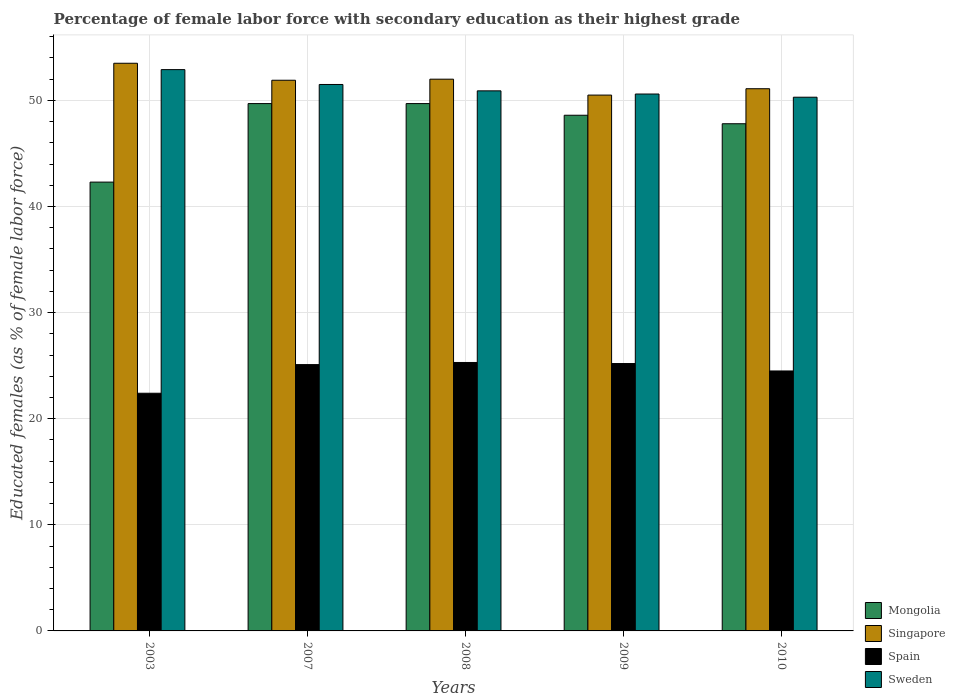How many different coloured bars are there?
Your answer should be compact. 4. Are the number of bars per tick equal to the number of legend labels?
Offer a terse response. Yes. How many bars are there on the 1st tick from the left?
Make the answer very short. 4. How many bars are there on the 4th tick from the right?
Make the answer very short. 4. What is the label of the 5th group of bars from the left?
Your answer should be compact. 2010. In how many cases, is the number of bars for a given year not equal to the number of legend labels?
Your answer should be very brief. 0. What is the percentage of female labor force with secondary education in Mongolia in 2008?
Provide a short and direct response. 49.7. Across all years, what is the maximum percentage of female labor force with secondary education in Spain?
Keep it short and to the point. 25.3. Across all years, what is the minimum percentage of female labor force with secondary education in Mongolia?
Your answer should be compact. 42.3. In which year was the percentage of female labor force with secondary education in Singapore maximum?
Make the answer very short. 2003. What is the total percentage of female labor force with secondary education in Mongolia in the graph?
Give a very brief answer. 238.1. What is the difference between the percentage of female labor force with secondary education in Sweden in 2007 and that in 2009?
Keep it short and to the point. 0.9. What is the average percentage of female labor force with secondary education in Sweden per year?
Ensure brevity in your answer.  51.24. In the year 2010, what is the difference between the percentage of female labor force with secondary education in Spain and percentage of female labor force with secondary education in Sweden?
Give a very brief answer. -25.8. In how many years, is the percentage of female labor force with secondary education in Mongolia greater than 4 %?
Provide a succinct answer. 5. What is the ratio of the percentage of female labor force with secondary education in Spain in 2008 to that in 2009?
Offer a terse response. 1. Is the percentage of female labor force with secondary education in Singapore in 2003 less than that in 2008?
Offer a very short reply. No. Is the difference between the percentage of female labor force with secondary education in Spain in 2003 and 2007 greater than the difference between the percentage of female labor force with secondary education in Sweden in 2003 and 2007?
Provide a succinct answer. No. What is the difference between the highest and the second highest percentage of female labor force with secondary education in Spain?
Offer a very short reply. 0.1. What is the difference between the highest and the lowest percentage of female labor force with secondary education in Singapore?
Provide a short and direct response. 3. Is it the case that in every year, the sum of the percentage of female labor force with secondary education in Spain and percentage of female labor force with secondary education in Singapore is greater than the sum of percentage of female labor force with secondary education in Mongolia and percentage of female labor force with secondary education in Sweden?
Your answer should be compact. No. What does the 2nd bar from the left in 2008 represents?
Your answer should be compact. Singapore. What does the 2nd bar from the right in 2008 represents?
Your answer should be compact. Spain. Is it the case that in every year, the sum of the percentage of female labor force with secondary education in Mongolia and percentage of female labor force with secondary education in Sweden is greater than the percentage of female labor force with secondary education in Singapore?
Offer a very short reply. Yes. How many bars are there?
Provide a short and direct response. 20. How many years are there in the graph?
Your answer should be compact. 5. Where does the legend appear in the graph?
Your answer should be compact. Bottom right. How many legend labels are there?
Provide a short and direct response. 4. How are the legend labels stacked?
Provide a short and direct response. Vertical. What is the title of the graph?
Make the answer very short. Percentage of female labor force with secondary education as their highest grade. What is the label or title of the Y-axis?
Offer a very short reply. Educated females (as % of female labor force). What is the Educated females (as % of female labor force) in Mongolia in 2003?
Offer a terse response. 42.3. What is the Educated females (as % of female labor force) of Singapore in 2003?
Keep it short and to the point. 53.5. What is the Educated females (as % of female labor force) of Spain in 2003?
Offer a very short reply. 22.4. What is the Educated females (as % of female labor force) in Sweden in 2003?
Your answer should be compact. 52.9. What is the Educated females (as % of female labor force) in Mongolia in 2007?
Your response must be concise. 49.7. What is the Educated females (as % of female labor force) in Singapore in 2007?
Offer a terse response. 51.9. What is the Educated females (as % of female labor force) of Spain in 2007?
Your answer should be very brief. 25.1. What is the Educated females (as % of female labor force) in Sweden in 2007?
Provide a short and direct response. 51.5. What is the Educated females (as % of female labor force) of Mongolia in 2008?
Provide a short and direct response. 49.7. What is the Educated females (as % of female labor force) in Singapore in 2008?
Offer a very short reply. 52. What is the Educated females (as % of female labor force) in Spain in 2008?
Keep it short and to the point. 25.3. What is the Educated females (as % of female labor force) of Sweden in 2008?
Provide a succinct answer. 50.9. What is the Educated females (as % of female labor force) of Mongolia in 2009?
Your answer should be very brief. 48.6. What is the Educated females (as % of female labor force) of Singapore in 2009?
Provide a succinct answer. 50.5. What is the Educated females (as % of female labor force) in Spain in 2009?
Give a very brief answer. 25.2. What is the Educated females (as % of female labor force) of Sweden in 2009?
Ensure brevity in your answer.  50.6. What is the Educated females (as % of female labor force) in Mongolia in 2010?
Provide a succinct answer. 47.8. What is the Educated females (as % of female labor force) of Singapore in 2010?
Provide a short and direct response. 51.1. What is the Educated females (as % of female labor force) of Sweden in 2010?
Provide a short and direct response. 50.3. Across all years, what is the maximum Educated females (as % of female labor force) in Mongolia?
Provide a short and direct response. 49.7. Across all years, what is the maximum Educated females (as % of female labor force) of Singapore?
Provide a succinct answer. 53.5. Across all years, what is the maximum Educated females (as % of female labor force) in Spain?
Your answer should be very brief. 25.3. Across all years, what is the maximum Educated females (as % of female labor force) in Sweden?
Your answer should be compact. 52.9. Across all years, what is the minimum Educated females (as % of female labor force) in Mongolia?
Your answer should be compact. 42.3. Across all years, what is the minimum Educated females (as % of female labor force) of Singapore?
Offer a terse response. 50.5. Across all years, what is the minimum Educated females (as % of female labor force) in Spain?
Make the answer very short. 22.4. Across all years, what is the minimum Educated females (as % of female labor force) in Sweden?
Provide a succinct answer. 50.3. What is the total Educated females (as % of female labor force) of Mongolia in the graph?
Provide a succinct answer. 238.1. What is the total Educated females (as % of female labor force) of Singapore in the graph?
Provide a succinct answer. 259. What is the total Educated females (as % of female labor force) of Spain in the graph?
Provide a short and direct response. 122.5. What is the total Educated females (as % of female labor force) of Sweden in the graph?
Provide a succinct answer. 256.2. What is the difference between the Educated females (as % of female labor force) of Mongolia in 2003 and that in 2007?
Offer a very short reply. -7.4. What is the difference between the Educated females (as % of female labor force) in Sweden in 2003 and that in 2007?
Provide a short and direct response. 1.4. What is the difference between the Educated females (as % of female labor force) in Mongolia in 2003 and that in 2008?
Your answer should be very brief. -7.4. What is the difference between the Educated females (as % of female labor force) of Singapore in 2003 and that in 2008?
Offer a terse response. 1.5. What is the difference between the Educated females (as % of female labor force) in Singapore in 2003 and that in 2009?
Make the answer very short. 3. What is the difference between the Educated females (as % of female labor force) of Sweden in 2003 and that in 2009?
Ensure brevity in your answer.  2.3. What is the difference between the Educated females (as % of female labor force) in Mongolia in 2003 and that in 2010?
Keep it short and to the point. -5.5. What is the difference between the Educated females (as % of female labor force) in Singapore in 2003 and that in 2010?
Provide a succinct answer. 2.4. What is the difference between the Educated females (as % of female labor force) in Mongolia in 2007 and that in 2008?
Keep it short and to the point. 0. What is the difference between the Educated females (as % of female labor force) of Sweden in 2007 and that in 2008?
Ensure brevity in your answer.  0.6. What is the difference between the Educated females (as % of female labor force) in Mongolia in 2007 and that in 2009?
Ensure brevity in your answer.  1.1. What is the difference between the Educated females (as % of female labor force) of Singapore in 2007 and that in 2010?
Offer a very short reply. 0.8. What is the difference between the Educated females (as % of female labor force) of Sweden in 2007 and that in 2010?
Give a very brief answer. 1.2. What is the difference between the Educated females (as % of female labor force) of Mongolia in 2008 and that in 2009?
Keep it short and to the point. 1.1. What is the difference between the Educated females (as % of female labor force) of Singapore in 2008 and that in 2009?
Ensure brevity in your answer.  1.5. What is the difference between the Educated females (as % of female labor force) in Singapore in 2008 and that in 2010?
Make the answer very short. 0.9. What is the difference between the Educated females (as % of female labor force) of Mongolia in 2009 and that in 2010?
Offer a terse response. 0.8. What is the difference between the Educated females (as % of female labor force) of Mongolia in 2003 and the Educated females (as % of female labor force) of Spain in 2007?
Ensure brevity in your answer.  17.2. What is the difference between the Educated females (as % of female labor force) in Singapore in 2003 and the Educated females (as % of female labor force) in Spain in 2007?
Offer a terse response. 28.4. What is the difference between the Educated females (as % of female labor force) in Singapore in 2003 and the Educated females (as % of female labor force) in Sweden in 2007?
Offer a very short reply. 2. What is the difference between the Educated females (as % of female labor force) in Spain in 2003 and the Educated females (as % of female labor force) in Sweden in 2007?
Make the answer very short. -29.1. What is the difference between the Educated females (as % of female labor force) in Mongolia in 2003 and the Educated females (as % of female labor force) in Singapore in 2008?
Provide a succinct answer. -9.7. What is the difference between the Educated females (as % of female labor force) in Mongolia in 2003 and the Educated females (as % of female labor force) in Spain in 2008?
Your answer should be compact. 17. What is the difference between the Educated females (as % of female labor force) in Singapore in 2003 and the Educated females (as % of female labor force) in Spain in 2008?
Offer a terse response. 28.2. What is the difference between the Educated females (as % of female labor force) in Spain in 2003 and the Educated females (as % of female labor force) in Sweden in 2008?
Your response must be concise. -28.5. What is the difference between the Educated females (as % of female labor force) in Mongolia in 2003 and the Educated females (as % of female labor force) in Spain in 2009?
Offer a very short reply. 17.1. What is the difference between the Educated females (as % of female labor force) in Mongolia in 2003 and the Educated females (as % of female labor force) in Sweden in 2009?
Your answer should be compact. -8.3. What is the difference between the Educated females (as % of female labor force) of Singapore in 2003 and the Educated females (as % of female labor force) of Spain in 2009?
Provide a succinct answer. 28.3. What is the difference between the Educated females (as % of female labor force) in Singapore in 2003 and the Educated females (as % of female labor force) in Sweden in 2009?
Make the answer very short. 2.9. What is the difference between the Educated females (as % of female labor force) of Spain in 2003 and the Educated females (as % of female labor force) of Sweden in 2009?
Offer a terse response. -28.2. What is the difference between the Educated females (as % of female labor force) of Mongolia in 2003 and the Educated females (as % of female labor force) of Sweden in 2010?
Provide a succinct answer. -8. What is the difference between the Educated females (as % of female labor force) of Singapore in 2003 and the Educated females (as % of female labor force) of Spain in 2010?
Your answer should be compact. 29. What is the difference between the Educated females (as % of female labor force) of Singapore in 2003 and the Educated females (as % of female labor force) of Sweden in 2010?
Offer a terse response. 3.2. What is the difference between the Educated females (as % of female labor force) of Spain in 2003 and the Educated females (as % of female labor force) of Sweden in 2010?
Provide a succinct answer. -27.9. What is the difference between the Educated females (as % of female labor force) of Mongolia in 2007 and the Educated females (as % of female labor force) of Singapore in 2008?
Offer a very short reply. -2.3. What is the difference between the Educated females (as % of female labor force) of Mongolia in 2007 and the Educated females (as % of female labor force) of Spain in 2008?
Your answer should be compact. 24.4. What is the difference between the Educated females (as % of female labor force) in Singapore in 2007 and the Educated females (as % of female labor force) in Spain in 2008?
Make the answer very short. 26.6. What is the difference between the Educated females (as % of female labor force) in Spain in 2007 and the Educated females (as % of female labor force) in Sweden in 2008?
Give a very brief answer. -25.8. What is the difference between the Educated females (as % of female labor force) in Singapore in 2007 and the Educated females (as % of female labor force) in Spain in 2009?
Provide a succinct answer. 26.7. What is the difference between the Educated females (as % of female labor force) in Singapore in 2007 and the Educated females (as % of female labor force) in Sweden in 2009?
Provide a succinct answer. 1.3. What is the difference between the Educated females (as % of female labor force) in Spain in 2007 and the Educated females (as % of female labor force) in Sweden in 2009?
Ensure brevity in your answer.  -25.5. What is the difference between the Educated females (as % of female labor force) of Mongolia in 2007 and the Educated females (as % of female labor force) of Spain in 2010?
Offer a terse response. 25.2. What is the difference between the Educated females (as % of female labor force) of Singapore in 2007 and the Educated females (as % of female labor force) of Spain in 2010?
Offer a terse response. 27.4. What is the difference between the Educated females (as % of female labor force) in Spain in 2007 and the Educated females (as % of female labor force) in Sweden in 2010?
Provide a succinct answer. -25.2. What is the difference between the Educated females (as % of female labor force) of Mongolia in 2008 and the Educated females (as % of female labor force) of Singapore in 2009?
Provide a succinct answer. -0.8. What is the difference between the Educated females (as % of female labor force) of Mongolia in 2008 and the Educated females (as % of female labor force) of Sweden in 2009?
Make the answer very short. -0.9. What is the difference between the Educated females (as % of female labor force) of Singapore in 2008 and the Educated females (as % of female labor force) of Spain in 2009?
Provide a succinct answer. 26.8. What is the difference between the Educated females (as % of female labor force) of Spain in 2008 and the Educated females (as % of female labor force) of Sweden in 2009?
Offer a very short reply. -25.3. What is the difference between the Educated females (as % of female labor force) of Mongolia in 2008 and the Educated females (as % of female labor force) of Spain in 2010?
Keep it short and to the point. 25.2. What is the difference between the Educated females (as % of female labor force) in Singapore in 2008 and the Educated females (as % of female labor force) in Spain in 2010?
Your answer should be very brief. 27.5. What is the difference between the Educated females (as % of female labor force) of Spain in 2008 and the Educated females (as % of female labor force) of Sweden in 2010?
Your answer should be very brief. -25. What is the difference between the Educated females (as % of female labor force) in Mongolia in 2009 and the Educated females (as % of female labor force) in Singapore in 2010?
Provide a short and direct response. -2.5. What is the difference between the Educated females (as % of female labor force) in Mongolia in 2009 and the Educated females (as % of female labor force) in Spain in 2010?
Your answer should be compact. 24.1. What is the difference between the Educated females (as % of female labor force) of Mongolia in 2009 and the Educated females (as % of female labor force) of Sweden in 2010?
Provide a short and direct response. -1.7. What is the difference between the Educated females (as % of female labor force) of Singapore in 2009 and the Educated females (as % of female labor force) of Spain in 2010?
Make the answer very short. 26. What is the difference between the Educated females (as % of female labor force) in Spain in 2009 and the Educated females (as % of female labor force) in Sweden in 2010?
Give a very brief answer. -25.1. What is the average Educated females (as % of female labor force) of Mongolia per year?
Keep it short and to the point. 47.62. What is the average Educated females (as % of female labor force) in Singapore per year?
Give a very brief answer. 51.8. What is the average Educated females (as % of female labor force) of Spain per year?
Offer a very short reply. 24.5. What is the average Educated females (as % of female labor force) in Sweden per year?
Ensure brevity in your answer.  51.24. In the year 2003, what is the difference between the Educated females (as % of female labor force) of Mongolia and Educated females (as % of female labor force) of Singapore?
Make the answer very short. -11.2. In the year 2003, what is the difference between the Educated females (as % of female labor force) of Singapore and Educated females (as % of female labor force) of Spain?
Your response must be concise. 31.1. In the year 2003, what is the difference between the Educated females (as % of female labor force) in Singapore and Educated females (as % of female labor force) in Sweden?
Ensure brevity in your answer.  0.6. In the year 2003, what is the difference between the Educated females (as % of female labor force) of Spain and Educated females (as % of female labor force) of Sweden?
Give a very brief answer. -30.5. In the year 2007, what is the difference between the Educated females (as % of female labor force) of Mongolia and Educated females (as % of female labor force) of Spain?
Make the answer very short. 24.6. In the year 2007, what is the difference between the Educated females (as % of female labor force) in Singapore and Educated females (as % of female labor force) in Spain?
Offer a terse response. 26.8. In the year 2007, what is the difference between the Educated females (as % of female labor force) of Singapore and Educated females (as % of female labor force) of Sweden?
Offer a terse response. 0.4. In the year 2007, what is the difference between the Educated females (as % of female labor force) in Spain and Educated females (as % of female labor force) in Sweden?
Keep it short and to the point. -26.4. In the year 2008, what is the difference between the Educated females (as % of female labor force) of Mongolia and Educated females (as % of female labor force) of Spain?
Ensure brevity in your answer.  24.4. In the year 2008, what is the difference between the Educated females (as % of female labor force) of Singapore and Educated females (as % of female labor force) of Spain?
Provide a short and direct response. 26.7. In the year 2008, what is the difference between the Educated females (as % of female labor force) of Singapore and Educated females (as % of female labor force) of Sweden?
Offer a terse response. 1.1. In the year 2008, what is the difference between the Educated females (as % of female labor force) in Spain and Educated females (as % of female labor force) in Sweden?
Provide a short and direct response. -25.6. In the year 2009, what is the difference between the Educated females (as % of female labor force) of Mongolia and Educated females (as % of female labor force) of Spain?
Your answer should be very brief. 23.4. In the year 2009, what is the difference between the Educated females (as % of female labor force) of Singapore and Educated females (as % of female labor force) of Spain?
Provide a short and direct response. 25.3. In the year 2009, what is the difference between the Educated females (as % of female labor force) in Singapore and Educated females (as % of female labor force) in Sweden?
Provide a succinct answer. -0.1. In the year 2009, what is the difference between the Educated females (as % of female labor force) of Spain and Educated females (as % of female labor force) of Sweden?
Ensure brevity in your answer.  -25.4. In the year 2010, what is the difference between the Educated females (as % of female labor force) in Mongolia and Educated females (as % of female labor force) in Spain?
Give a very brief answer. 23.3. In the year 2010, what is the difference between the Educated females (as % of female labor force) of Mongolia and Educated females (as % of female labor force) of Sweden?
Ensure brevity in your answer.  -2.5. In the year 2010, what is the difference between the Educated females (as % of female labor force) in Singapore and Educated females (as % of female labor force) in Spain?
Your answer should be very brief. 26.6. In the year 2010, what is the difference between the Educated females (as % of female labor force) in Spain and Educated females (as % of female labor force) in Sweden?
Provide a short and direct response. -25.8. What is the ratio of the Educated females (as % of female labor force) in Mongolia in 2003 to that in 2007?
Ensure brevity in your answer.  0.85. What is the ratio of the Educated females (as % of female labor force) in Singapore in 2003 to that in 2007?
Your response must be concise. 1.03. What is the ratio of the Educated females (as % of female labor force) of Spain in 2003 to that in 2007?
Give a very brief answer. 0.89. What is the ratio of the Educated females (as % of female labor force) in Sweden in 2003 to that in 2007?
Ensure brevity in your answer.  1.03. What is the ratio of the Educated females (as % of female labor force) of Mongolia in 2003 to that in 2008?
Your answer should be compact. 0.85. What is the ratio of the Educated females (as % of female labor force) in Singapore in 2003 to that in 2008?
Give a very brief answer. 1.03. What is the ratio of the Educated females (as % of female labor force) of Spain in 2003 to that in 2008?
Provide a short and direct response. 0.89. What is the ratio of the Educated females (as % of female labor force) of Sweden in 2003 to that in 2008?
Offer a very short reply. 1.04. What is the ratio of the Educated females (as % of female labor force) of Mongolia in 2003 to that in 2009?
Give a very brief answer. 0.87. What is the ratio of the Educated females (as % of female labor force) in Singapore in 2003 to that in 2009?
Provide a short and direct response. 1.06. What is the ratio of the Educated females (as % of female labor force) in Sweden in 2003 to that in 2009?
Ensure brevity in your answer.  1.05. What is the ratio of the Educated females (as % of female labor force) in Mongolia in 2003 to that in 2010?
Make the answer very short. 0.88. What is the ratio of the Educated females (as % of female labor force) in Singapore in 2003 to that in 2010?
Offer a terse response. 1.05. What is the ratio of the Educated females (as % of female labor force) in Spain in 2003 to that in 2010?
Offer a terse response. 0.91. What is the ratio of the Educated females (as % of female labor force) in Sweden in 2003 to that in 2010?
Ensure brevity in your answer.  1.05. What is the ratio of the Educated females (as % of female labor force) of Singapore in 2007 to that in 2008?
Offer a very short reply. 1. What is the ratio of the Educated females (as % of female labor force) of Sweden in 2007 to that in 2008?
Give a very brief answer. 1.01. What is the ratio of the Educated females (as % of female labor force) of Mongolia in 2007 to that in 2009?
Your response must be concise. 1.02. What is the ratio of the Educated females (as % of female labor force) of Singapore in 2007 to that in 2009?
Your answer should be compact. 1.03. What is the ratio of the Educated females (as % of female labor force) in Sweden in 2007 to that in 2009?
Keep it short and to the point. 1.02. What is the ratio of the Educated females (as % of female labor force) in Mongolia in 2007 to that in 2010?
Ensure brevity in your answer.  1.04. What is the ratio of the Educated females (as % of female labor force) in Singapore in 2007 to that in 2010?
Your answer should be compact. 1.02. What is the ratio of the Educated females (as % of female labor force) in Spain in 2007 to that in 2010?
Make the answer very short. 1.02. What is the ratio of the Educated females (as % of female labor force) of Sweden in 2007 to that in 2010?
Give a very brief answer. 1.02. What is the ratio of the Educated females (as % of female labor force) in Mongolia in 2008 to that in 2009?
Provide a short and direct response. 1.02. What is the ratio of the Educated females (as % of female labor force) of Singapore in 2008 to that in 2009?
Offer a very short reply. 1.03. What is the ratio of the Educated females (as % of female labor force) in Sweden in 2008 to that in 2009?
Your answer should be compact. 1.01. What is the ratio of the Educated females (as % of female labor force) in Mongolia in 2008 to that in 2010?
Give a very brief answer. 1.04. What is the ratio of the Educated females (as % of female labor force) of Singapore in 2008 to that in 2010?
Provide a short and direct response. 1.02. What is the ratio of the Educated females (as % of female labor force) of Spain in 2008 to that in 2010?
Provide a short and direct response. 1.03. What is the ratio of the Educated females (as % of female labor force) in Sweden in 2008 to that in 2010?
Your response must be concise. 1.01. What is the ratio of the Educated females (as % of female labor force) in Mongolia in 2009 to that in 2010?
Your response must be concise. 1.02. What is the ratio of the Educated females (as % of female labor force) in Singapore in 2009 to that in 2010?
Make the answer very short. 0.99. What is the ratio of the Educated females (as % of female labor force) in Spain in 2009 to that in 2010?
Make the answer very short. 1.03. What is the ratio of the Educated females (as % of female labor force) in Sweden in 2009 to that in 2010?
Keep it short and to the point. 1.01. What is the difference between the highest and the second highest Educated females (as % of female labor force) of Mongolia?
Your response must be concise. 0. What is the difference between the highest and the second highest Educated females (as % of female labor force) of Singapore?
Your response must be concise. 1.5. What is the difference between the highest and the second highest Educated females (as % of female labor force) of Spain?
Your answer should be compact. 0.1. What is the difference between the highest and the lowest Educated females (as % of female labor force) of Singapore?
Keep it short and to the point. 3. What is the difference between the highest and the lowest Educated females (as % of female labor force) in Spain?
Offer a terse response. 2.9. 